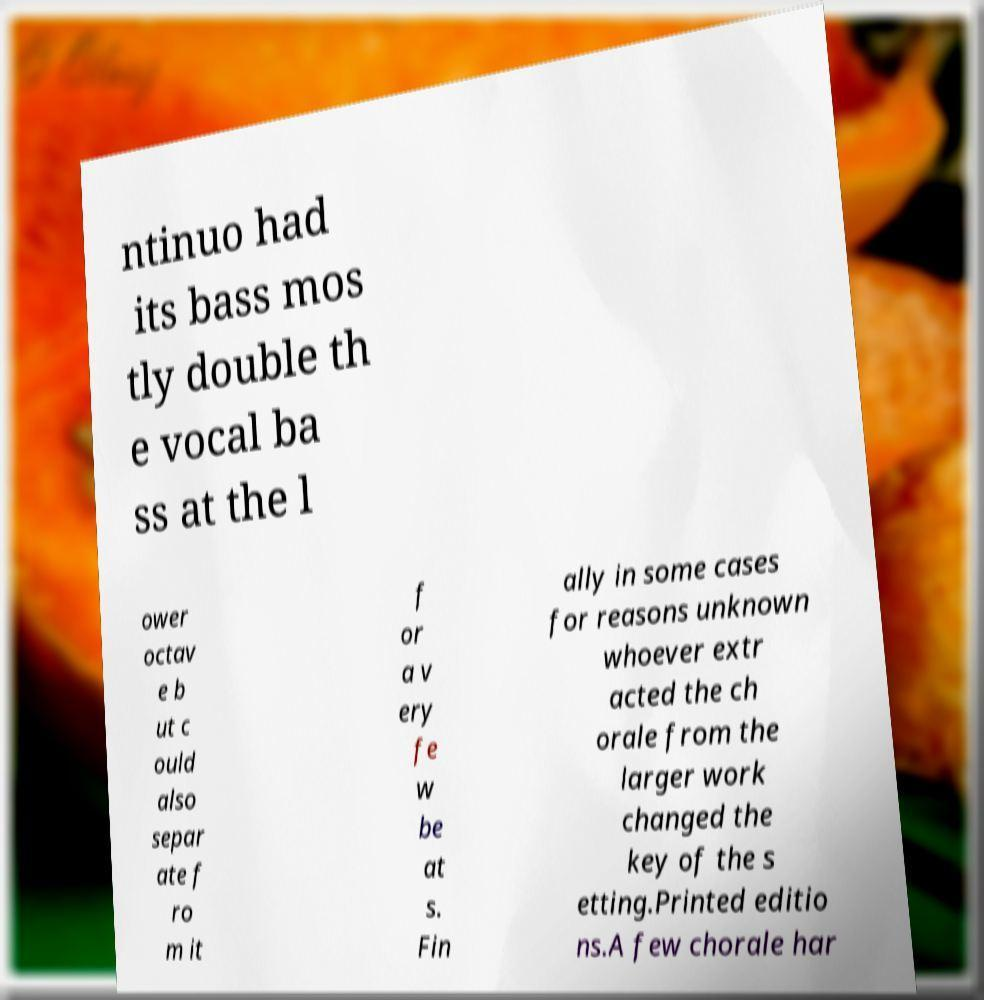Can you read and provide the text displayed in the image?This photo seems to have some interesting text. Can you extract and type it out for me? ntinuo had its bass mos tly double th e vocal ba ss at the l ower octav e b ut c ould also separ ate f ro m it f or a v ery fe w be at s. Fin ally in some cases for reasons unknown whoever extr acted the ch orale from the larger work changed the key of the s etting.Printed editio ns.A few chorale har 